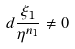Convert formula to latex. <formula><loc_0><loc_0><loc_500><loc_500>d \frac { \xi _ { 1 } } { \eta ^ { n _ { 1 } } } \neq 0</formula> 